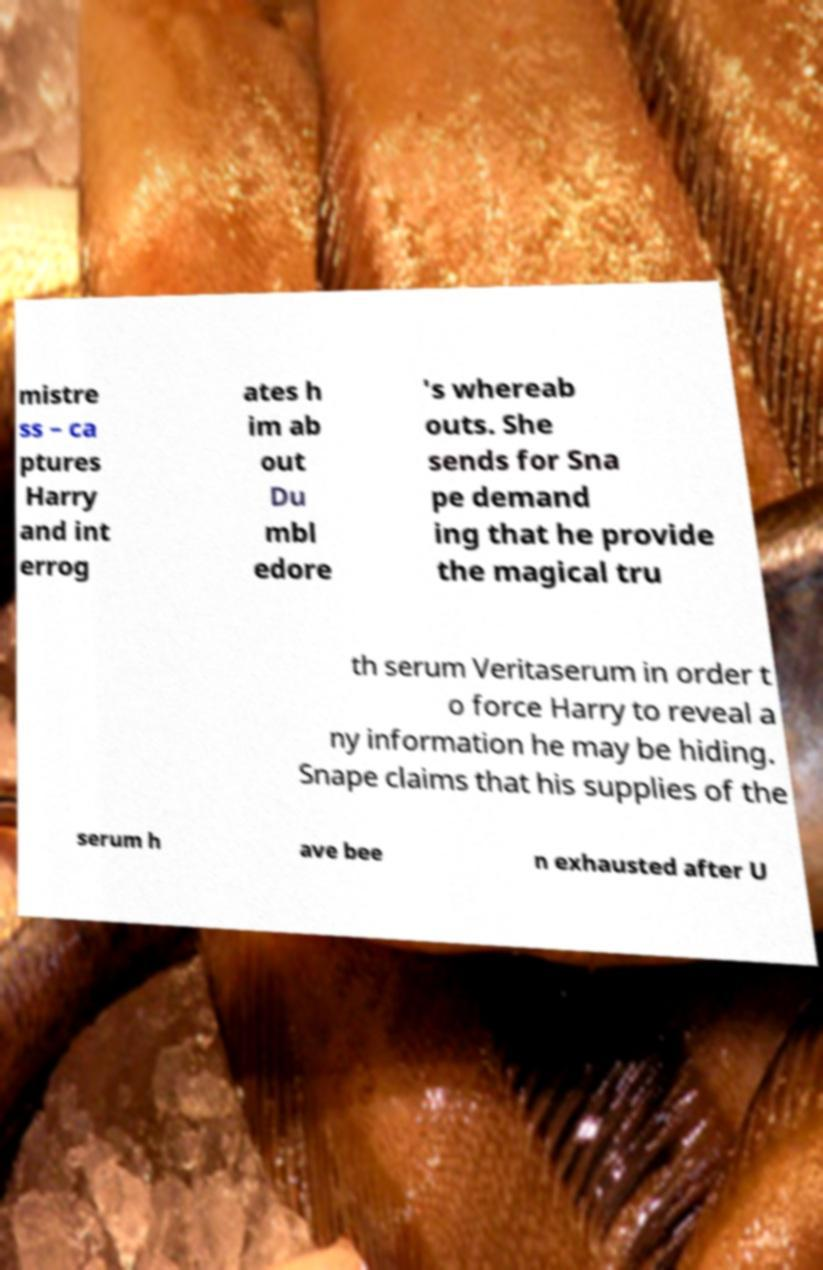Can you read and provide the text displayed in the image?This photo seems to have some interesting text. Can you extract and type it out for me? mistre ss – ca ptures Harry and int errog ates h im ab out Du mbl edore 's whereab outs. She sends for Sna pe demand ing that he provide the magical tru th serum Veritaserum in order t o force Harry to reveal a ny information he may be hiding. Snape claims that his supplies of the serum h ave bee n exhausted after U 